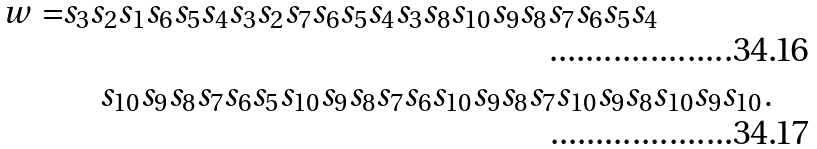Convert formula to latex. <formula><loc_0><loc_0><loc_500><loc_500>w = & s _ { 3 } s _ { 2 } s _ { 1 } s _ { 6 } s _ { 5 } s _ { 4 } s _ { 3 } s _ { 2 } s _ { 7 } s _ { 6 } s _ { 5 } s _ { 4 } s _ { 3 } s _ { 8 } s _ { 1 0 } s _ { 9 } s _ { 8 } s _ { 7 } s _ { 6 } s _ { 5 } s _ { 4 } \\ & \quad s _ { 1 0 } s _ { 9 } s _ { 8 } s _ { 7 } s _ { 6 } s _ { 5 } s _ { 1 0 } s _ { 9 } s _ { 8 } s _ { 7 } s _ { 6 } s _ { 1 0 } s _ { 9 } s _ { 8 } s _ { 7 } s _ { 1 0 } s _ { 9 } s _ { 8 } s _ { 1 0 } s _ { 9 } s _ { 1 0 } .</formula> 